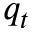Convert formula to latex. <formula><loc_0><loc_0><loc_500><loc_500>q _ { t }</formula> 